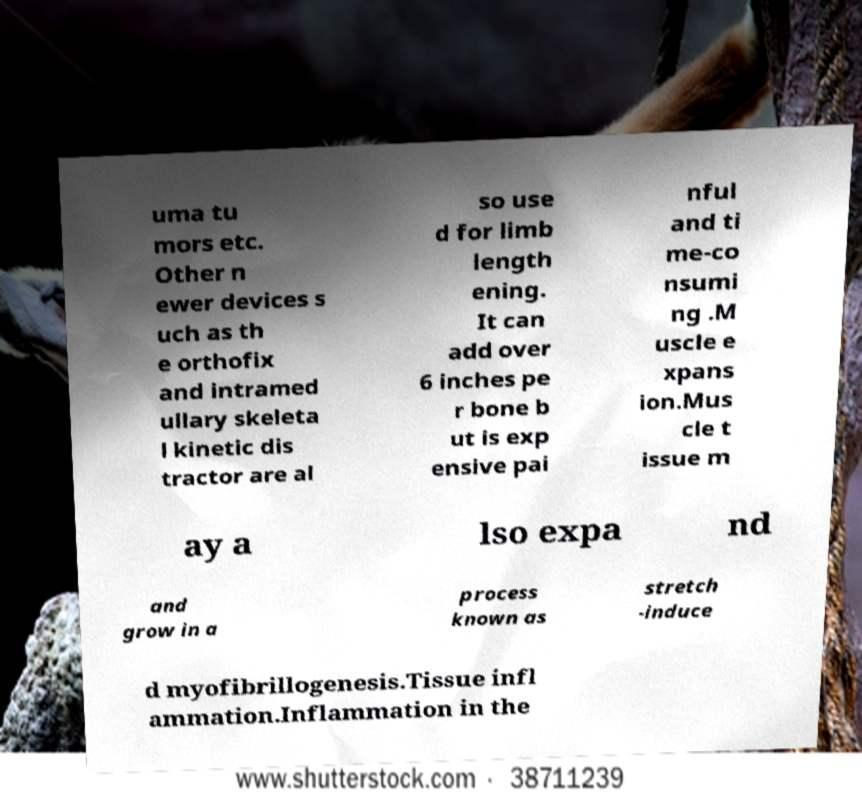For documentation purposes, I need the text within this image transcribed. Could you provide that? uma tu mors etc. Other n ewer devices s uch as th e orthofix and intramed ullary skeleta l kinetic dis tractor are al so use d for limb length ening. It can add over 6 inches pe r bone b ut is exp ensive pai nful and ti me-co nsumi ng .M uscle e xpans ion.Mus cle t issue m ay a lso expa nd and grow in a process known as stretch -induce d myofibrillogenesis.Tissue infl ammation.Inflammation in the 